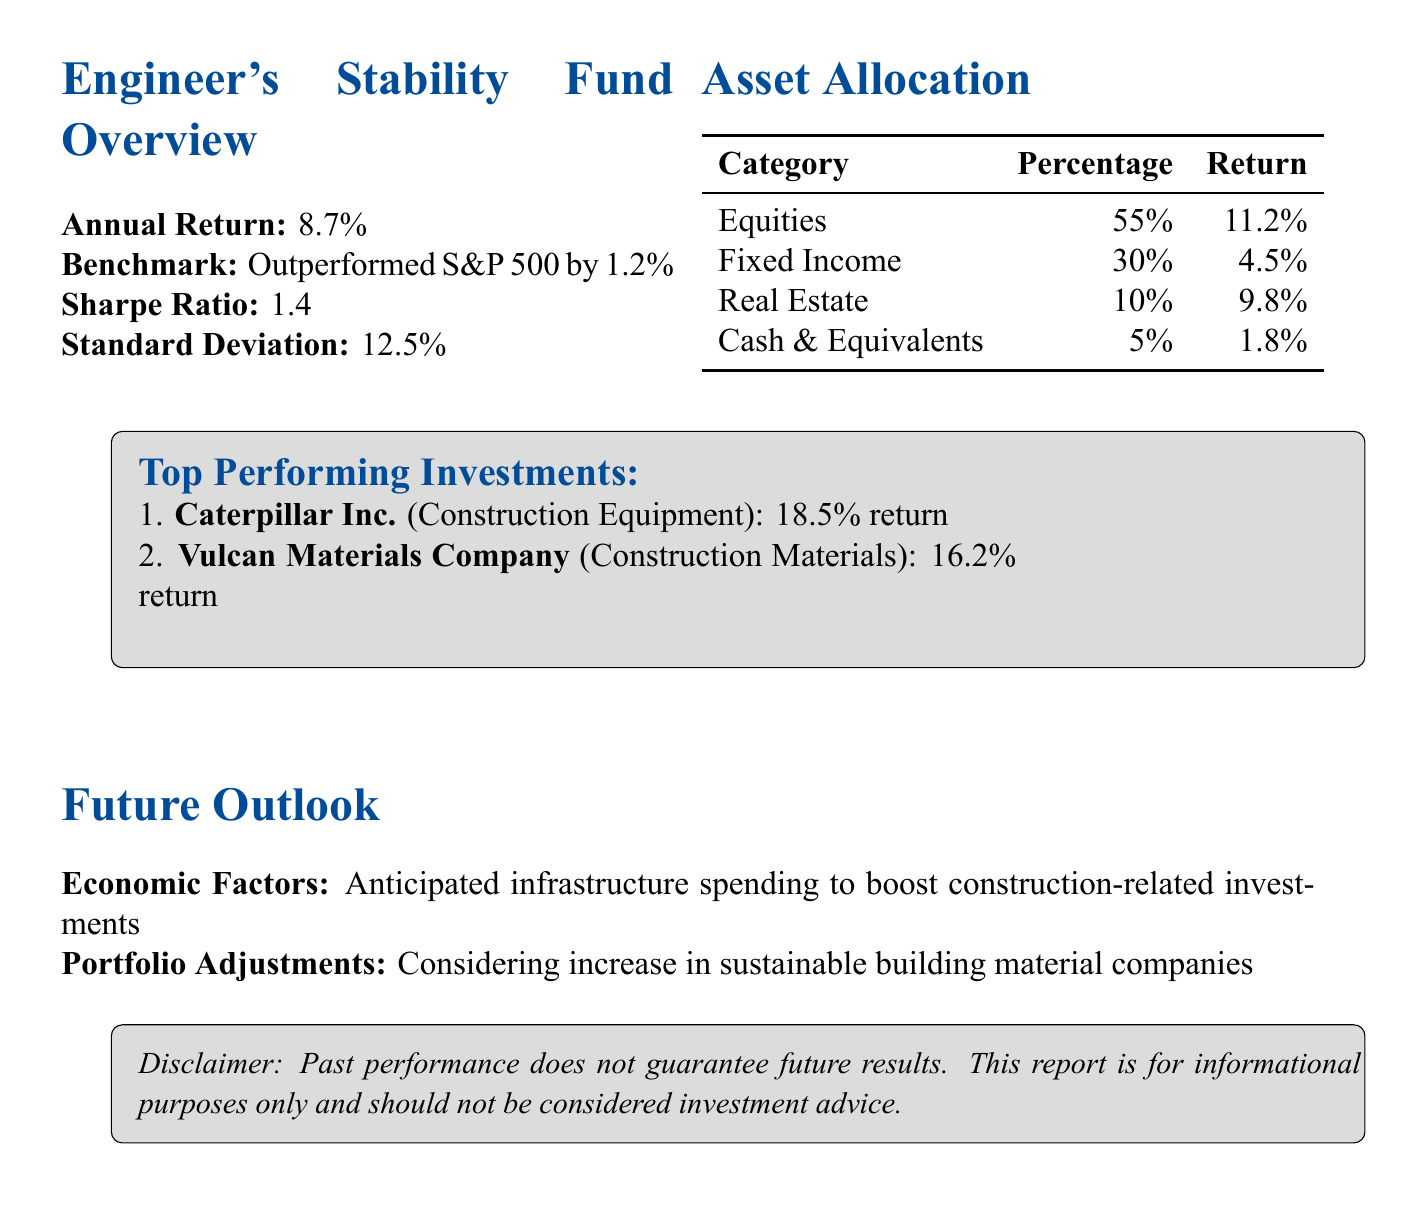What is the annual return of the fund? The annual return is the percentage increase in the fund's value over the year, which is stated as 8.7%.
Answer: 8.7% Which benchmark did the fund outperform? The document mentions that the fund outperformed a specific benchmark, which is the S&P 500.
Answer: S&P 500 What is the return percentage for Real Estate investments? The return for the Real Estate category is provided in the asset allocation section, which is 9.8%.
Answer: 9.8% What is the Sharpe Ratio of the fund? The Sharpe Ratio is given in the risk analysis section and indicates the risk-adjusted return of the fund, which is 1.4.
Answer: 1.4 Which company had the highest return among top investments? The document lists the returns of top-performing investments, where Caterpillar Inc. has the highest return of 18.5%.
Answer: Caterpillar Inc How much of the portfolio is allocated to Fixed Income? The document specifies the percentage allocated to Fixed Income in the asset allocation section, which is 30%.
Answer: 30% What economic factor is expected to influence future investments? The future outlook section mentions anticipated infrastructure spending as a factor expected to influence investments.
Answer: Infrastructure spending What is the total percentage allocation in Equities and Real Estate combined? By adding the individual allocations from the asset allocation section, 55% (Equities) + 10% (Real Estate) gives a total of 65%.
Answer: 65% 